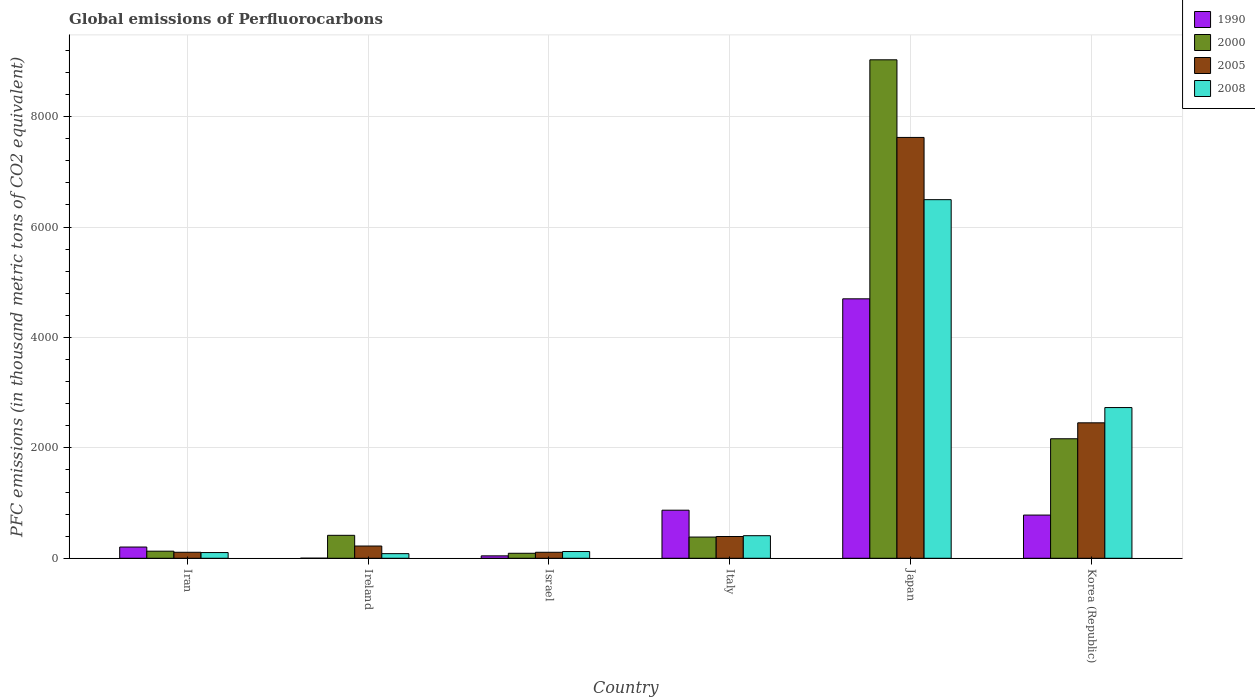How many different coloured bars are there?
Offer a very short reply. 4. Are the number of bars per tick equal to the number of legend labels?
Your answer should be compact. Yes. How many bars are there on the 2nd tick from the right?
Give a very brief answer. 4. What is the label of the 4th group of bars from the left?
Provide a succinct answer. Italy. In how many cases, is the number of bars for a given country not equal to the number of legend labels?
Your answer should be very brief. 0. What is the global emissions of Perfluorocarbons in 2008 in Japan?
Offer a terse response. 6496.1. Across all countries, what is the maximum global emissions of Perfluorocarbons in 2008?
Give a very brief answer. 6496.1. Across all countries, what is the minimum global emissions of Perfluorocarbons in 2008?
Offer a very short reply. 83.6. In which country was the global emissions of Perfluorocarbons in 2008 minimum?
Give a very brief answer. Ireland. What is the total global emissions of Perfluorocarbons in 2000 in the graph?
Your answer should be very brief. 1.22e+04. What is the difference between the global emissions of Perfluorocarbons in 2005 in Iran and that in Israel?
Make the answer very short. -0.2. What is the difference between the global emissions of Perfluorocarbons in 2000 in Iran and the global emissions of Perfluorocarbons in 2008 in Italy?
Give a very brief answer. -280.3. What is the average global emissions of Perfluorocarbons in 2000 per country?
Make the answer very short. 2035.6. What is the difference between the global emissions of Perfluorocarbons of/in 1990 and global emissions of Perfluorocarbons of/in 2008 in Japan?
Offer a terse response. -1796.1. In how many countries, is the global emissions of Perfluorocarbons in 2000 greater than 5600 thousand metric tons?
Provide a short and direct response. 1. What is the ratio of the global emissions of Perfluorocarbons in 1990 in Israel to that in Italy?
Your answer should be compact. 0.05. Is the difference between the global emissions of Perfluorocarbons in 1990 in Israel and Italy greater than the difference between the global emissions of Perfluorocarbons in 2008 in Israel and Italy?
Make the answer very short. No. What is the difference between the highest and the second highest global emissions of Perfluorocarbons in 2008?
Ensure brevity in your answer.  3766. What is the difference between the highest and the lowest global emissions of Perfluorocarbons in 2005?
Your answer should be very brief. 7515.1. In how many countries, is the global emissions of Perfluorocarbons in 1990 greater than the average global emissions of Perfluorocarbons in 1990 taken over all countries?
Offer a terse response. 1. What does the 1st bar from the left in Italy represents?
Your answer should be compact. 1990. What does the 1st bar from the right in Italy represents?
Provide a succinct answer. 2008. Is it the case that in every country, the sum of the global emissions of Perfluorocarbons in 1990 and global emissions of Perfluorocarbons in 2000 is greater than the global emissions of Perfluorocarbons in 2008?
Provide a succinct answer. Yes. Are all the bars in the graph horizontal?
Offer a very short reply. No. What is the difference between two consecutive major ticks on the Y-axis?
Ensure brevity in your answer.  2000. Are the values on the major ticks of Y-axis written in scientific E-notation?
Make the answer very short. No. Does the graph contain grids?
Your answer should be compact. Yes. Where does the legend appear in the graph?
Ensure brevity in your answer.  Top right. How are the legend labels stacked?
Make the answer very short. Vertical. What is the title of the graph?
Offer a terse response. Global emissions of Perfluorocarbons. What is the label or title of the Y-axis?
Provide a succinct answer. PFC emissions (in thousand metric tons of CO2 equivalent). What is the PFC emissions (in thousand metric tons of CO2 equivalent) of 1990 in Iran?
Offer a very short reply. 203.5. What is the PFC emissions (in thousand metric tons of CO2 equivalent) of 2000 in Iran?
Offer a terse response. 128.5. What is the PFC emissions (in thousand metric tons of CO2 equivalent) in 2005 in Iran?
Offer a very short reply. 108.5. What is the PFC emissions (in thousand metric tons of CO2 equivalent) of 2008 in Iran?
Give a very brief answer. 103.6. What is the PFC emissions (in thousand metric tons of CO2 equivalent) of 2000 in Ireland?
Keep it short and to the point. 415.6. What is the PFC emissions (in thousand metric tons of CO2 equivalent) of 2005 in Ireland?
Make the answer very short. 221.8. What is the PFC emissions (in thousand metric tons of CO2 equivalent) in 2008 in Ireland?
Your response must be concise. 83.6. What is the PFC emissions (in thousand metric tons of CO2 equivalent) in 1990 in Israel?
Your answer should be very brief. 43.8. What is the PFC emissions (in thousand metric tons of CO2 equivalent) of 2000 in Israel?
Offer a terse response. 90.5. What is the PFC emissions (in thousand metric tons of CO2 equivalent) of 2005 in Israel?
Give a very brief answer. 108.7. What is the PFC emissions (in thousand metric tons of CO2 equivalent) in 2008 in Israel?
Offer a very short reply. 122.3. What is the PFC emissions (in thousand metric tons of CO2 equivalent) in 1990 in Italy?
Provide a short and direct response. 871. What is the PFC emissions (in thousand metric tons of CO2 equivalent) of 2000 in Italy?
Your response must be concise. 384.3. What is the PFC emissions (in thousand metric tons of CO2 equivalent) of 2005 in Italy?
Give a very brief answer. 394.3. What is the PFC emissions (in thousand metric tons of CO2 equivalent) in 2008 in Italy?
Ensure brevity in your answer.  408.8. What is the PFC emissions (in thousand metric tons of CO2 equivalent) in 1990 in Japan?
Provide a succinct answer. 4700. What is the PFC emissions (in thousand metric tons of CO2 equivalent) of 2000 in Japan?
Offer a very short reply. 9029.8. What is the PFC emissions (in thousand metric tons of CO2 equivalent) of 2005 in Japan?
Your answer should be very brief. 7623.6. What is the PFC emissions (in thousand metric tons of CO2 equivalent) of 2008 in Japan?
Make the answer very short. 6496.1. What is the PFC emissions (in thousand metric tons of CO2 equivalent) of 1990 in Korea (Republic)?
Keep it short and to the point. 782.6. What is the PFC emissions (in thousand metric tons of CO2 equivalent) of 2000 in Korea (Republic)?
Provide a succinct answer. 2164.9. What is the PFC emissions (in thousand metric tons of CO2 equivalent) in 2005 in Korea (Republic)?
Ensure brevity in your answer.  2453.7. What is the PFC emissions (in thousand metric tons of CO2 equivalent) of 2008 in Korea (Republic)?
Your answer should be very brief. 2730.1. Across all countries, what is the maximum PFC emissions (in thousand metric tons of CO2 equivalent) of 1990?
Provide a succinct answer. 4700. Across all countries, what is the maximum PFC emissions (in thousand metric tons of CO2 equivalent) in 2000?
Your answer should be compact. 9029.8. Across all countries, what is the maximum PFC emissions (in thousand metric tons of CO2 equivalent) in 2005?
Offer a terse response. 7623.6. Across all countries, what is the maximum PFC emissions (in thousand metric tons of CO2 equivalent) of 2008?
Your answer should be compact. 6496.1. Across all countries, what is the minimum PFC emissions (in thousand metric tons of CO2 equivalent) of 1990?
Keep it short and to the point. 1.4. Across all countries, what is the minimum PFC emissions (in thousand metric tons of CO2 equivalent) of 2000?
Provide a short and direct response. 90.5. Across all countries, what is the minimum PFC emissions (in thousand metric tons of CO2 equivalent) of 2005?
Offer a very short reply. 108.5. Across all countries, what is the minimum PFC emissions (in thousand metric tons of CO2 equivalent) of 2008?
Your response must be concise. 83.6. What is the total PFC emissions (in thousand metric tons of CO2 equivalent) of 1990 in the graph?
Give a very brief answer. 6602.3. What is the total PFC emissions (in thousand metric tons of CO2 equivalent) in 2000 in the graph?
Provide a succinct answer. 1.22e+04. What is the total PFC emissions (in thousand metric tons of CO2 equivalent) in 2005 in the graph?
Make the answer very short. 1.09e+04. What is the total PFC emissions (in thousand metric tons of CO2 equivalent) in 2008 in the graph?
Your answer should be very brief. 9944.5. What is the difference between the PFC emissions (in thousand metric tons of CO2 equivalent) in 1990 in Iran and that in Ireland?
Ensure brevity in your answer.  202.1. What is the difference between the PFC emissions (in thousand metric tons of CO2 equivalent) in 2000 in Iran and that in Ireland?
Give a very brief answer. -287.1. What is the difference between the PFC emissions (in thousand metric tons of CO2 equivalent) of 2005 in Iran and that in Ireland?
Keep it short and to the point. -113.3. What is the difference between the PFC emissions (in thousand metric tons of CO2 equivalent) of 2008 in Iran and that in Ireland?
Make the answer very short. 20. What is the difference between the PFC emissions (in thousand metric tons of CO2 equivalent) in 1990 in Iran and that in Israel?
Provide a short and direct response. 159.7. What is the difference between the PFC emissions (in thousand metric tons of CO2 equivalent) of 2000 in Iran and that in Israel?
Your response must be concise. 38. What is the difference between the PFC emissions (in thousand metric tons of CO2 equivalent) of 2005 in Iran and that in Israel?
Keep it short and to the point. -0.2. What is the difference between the PFC emissions (in thousand metric tons of CO2 equivalent) of 2008 in Iran and that in Israel?
Your response must be concise. -18.7. What is the difference between the PFC emissions (in thousand metric tons of CO2 equivalent) in 1990 in Iran and that in Italy?
Offer a terse response. -667.5. What is the difference between the PFC emissions (in thousand metric tons of CO2 equivalent) of 2000 in Iran and that in Italy?
Your answer should be compact. -255.8. What is the difference between the PFC emissions (in thousand metric tons of CO2 equivalent) in 2005 in Iran and that in Italy?
Provide a short and direct response. -285.8. What is the difference between the PFC emissions (in thousand metric tons of CO2 equivalent) in 2008 in Iran and that in Italy?
Your response must be concise. -305.2. What is the difference between the PFC emissions (in thousand metric tons of CO2 equivalent) of 1990 in Iran and that in Japan?
Your response must be concise. -4496.5. What is the difference between the PFC emissions (in thousand metric tons of CO2 equivalent) of 2000 in Iran and that in Japan?
Offer a terse response. -8901.3. What is the difference between the PFC emissions (in thousand metric tons of CO2 equivalent) in 2005 in Iran and that in Japan?
Provide a short and direct response. -7515.1. What is the difference between the PFC emissions (in thousand metric tons of CO2 equivalent) in 2008 in Iran and that in Japan?
Your answer should be very brief. -6392.5. What is the difference between the PFC emissions (in thousand metric tons of CO2 equivalent) in 1990 in Iran and that in Korea (Republic)?
Your answer should be very brief. -579.1. What is the difference between the PFC emissions (in thousand metric tons of CO2 equivalent) in 2000 in Iran and that in Korea (Republic)?
Offer a very short reply. -2036.4. What is the difference between the PFC emissions (in thousand metric tons of CO2 equivalent) of 2005 in Iran and that in Korea (Republic)?
Keep it short and to the point. -2345.2. What is the difference between the PFC emissions (in thousand metric tons of CO2 equivalent) in 2008 in Iran and that in Korea (Republic)?
Give a very brief answer. -2626.5. What is the difference between the PFC emissions (in thousand metric tons of CO2 equivalent) of 1990 in Ireland and that in Israel?
Offer a terse response. -42.4. What is the difference between the PFC emissions (in thousand metric tons of CO2 equivalent) in 2000 in Ireland and that in Israel?
Offer a terse response. 325.1. What is the difference between the PFC emissions (in thousand metric tons of CO2 equivalent) of 2005 in Ireland and that in Israel?
Make the answer very short. 113.1. What is the difference between the PFC emissions (in thousand metric tons of CO2 equivalent) of 2008 in Ireland and that in Israel?
Your response must be concise. -38.7. What is the difference between the PFC emissions (in thousand metric tons of CO2 equivalent) in 1990 in Ireland and that in Italy?
Provide a succinct answer. -869.6. What is the difference between the PFC emissions (in thousand metric tons of CO2 equivalent) in 2000 in Ireland and that in Italy?
Offer a very short reply. 31.3. What is the difference between the PFC emissions (in thousand metric tons of CO2 equivalent) in 2005 in Ireland and that in Italy?
Your answer should be compact. -172.5. What is the difference between the PFC emissions (in thousand metric tons of CO2 equivalent) of 2008 in Ireland and that in Italy?
Give a very brief answer. -325.2. What is the difference between the PFC emissions (in thousand metric tons of CO2 equivalent) in 1990 in Ireland and that in Japan?
Your answer should be very brief. -4698.6. What is the difference between the PFC emissions (in thousand metric tons of CO2 equivalent) of 2000 in Ireland and that in Japan?
Make the answer very short. -8614.2. What is the difference between the PFC emissions (in thousand metric tons of CO2 equivalent) in 2005 in Ireland and that in Japan?
Your answer should be very brief. -7401.8. What is the difference between the PFC emissions (in thousand metric tons of CO2 equivalent) in 2008 in Ireland and that in Japan?
Provide a short and direct response. -6412.5. What is the difference between the PFC emissions (in thousand metric tons of CO2 equivalent) in 1990 in Ireland and that in Korea (Republic)?
Provide a short and direct response. -781.2. What is the difference between the PFC emissions (in thousand metric tons of CO2 equivalent) of 2000 in Ireland and that in Korea (Republic)?
Make the answer very short. -1749.3. What is the difference between the PFC emissions (in thousand metric tons of CO2 equivalent) in 2005 in Ireland and that in Korea (Republic)?
Ensure brevity in your answer.  -2231.9. What is the difference between the PFC emissions (in thousand metric tons of CO2 equivalent) in 2008 in Ireland and that in Korea (Republic)?
Give a very brief answer. -2646.5. What is the difference between the PFC emissions (in thousand metric tons of CO2 equivalent) of 1990 in Israel and that in Italy?
Make the answer very short. -827.2. What is the difference between the PFC emissions (in thousand metric tons of CO2 equivalent) of 2000 in Israel and that in Italy?
Provide a short and direct response. -293.8. What is the difference between the PFC emissions (in thousand metric tons of CO2 equivalent) of 2005 in Israel and that in Italy?
Offer a terse response. -285.6. What is the difference between the PFC emissions (in thousand metric tons of CO2 equivalent) of 2008 in Israel and that in Italy?
Give a very brief answer. -286.5. What is the difference between the PFC emissions (in thousand metric tons of CO2 equivalent) of 1990 in Israel and that in Japan?
Offer a very short reply. -4656.2. What is the difference between the PFC emissions (in thousand metric tons of CO2 equivalent) of 2000 in Israel and that in Japan?
Provide a succinct answer. -8939.3. What is the difference between the PFC emissions (in thousand metric tons of CO2 equivalent) of 2005 in Israel and that in Japan?
Your response must be concise. -7514.9. What is the difference between the PFC emissions (in thousand metric tons of CO2 equivalent) in 2008 in Israel and that in Japan?
Your answer should be compact. -6373.8. What is the difference between the PFC emissions (in thousand metric tons of CO2 equivalent) in 1990 in Israel and that in Korea (Republic)?
Keep it short and to the point. -738.8. What is the difference between the PFC emissions (in thousand metric tons of CO2 equivalent) of 2000 in Israel and that in Korea (Republic)?
Make the answer very short. -2074.4. What is the difference between the PFC emissions (in thousand metric tons of CO2 equivalent) in 2005 in Israel and that in Korea (Republic)?
Your answer should be very brief. -2345. What is the difference between the PFC emissions (in thousand metric tons of CO2 equivalent) in 2008 in Israel and that in Korea (Republic)?
Your answer should be very brief. -2607.8. What is the difference between the PFC emissions (in thousand metric tons of CO2 equivalent) of 1990 in Italy and that in Japan?
Make the answer very short. -3829. What is the difference between the PFC emissions (in thousand metric tons of CO2 equivalent) of 2000 in Italy and that in Japan?
Give a very brief answer. -8645.5. What is the difference between the PFC emissions (in thousand metric tons of CO2 equivalent) of 2005 in Italy and that in Japan?
Offer a terse response. -7229.3. What is the difference between the PFC emissions (in thousand metric tons of CO2 equivalent) in 2008 in Italy and that in Japan?
Offer a very short reply. -6087.3. What is the difference between the PFC emissions (in thousand metric tons of CO2 equivalent) of 1990 in Italy and that in Korea (Republic)?
Offer a terse response. 88.4. What is the difference between the PFC emissions (in thousand metric tons of CO2 equivalent) in 2000 in Italy and that in Korea (Republic)?
Offer a terse response. -1780.6. What is the difference between the PFC emissions (in thousand metric tons of CO2 equivalent) in 2005 in Italy and that in Korea (Republic)?
Your response must be concise. -2059.4. What is the difference between the PFC emissions (in thousand metric tons of CO2 equivalent) in 2008 in Italy and that in Korea (Republic)?
Offer a very short reply. -2321.3. What is the difference between the PFC emissions (in thousand metric tons of CO2 equivalent) in 1990 in Japan and that in Korea (Republic)?
Provide a succinct answer. 3917.4. What is the difference between the PFC emissions (in thousand metric tons of CO2 equivalent) of 2000 in Japan and that in Korea (Republic)?
Make the answer very short. 6864.9. What is the difference between the PFC emissions (in thousand metric tons of CO2 equivalent) in 2005 in Japan and that in Korea (Republic)?
Offer a very short reply. 5169.9. What is the difference between the PFC emissions (in thousand metric tons of CO2 equivalent) of 2008 in Japan and that in Korea (Republic)?
Keep it short and to the point. 3766. What is the difference between the PFC emissions (in thousand metric tons of CO2 equivalent) of 1990 in Iran and the PFC emissions (in thousand metric tons of CO2 equivalent) of 2000 in Ireland?
Offer a terse response. -212.1. What is the difference between the PFC emissions (in thousand metric tons of CO2 equivalent) of 1990 in Iran and the PFC emissions (in thousand metric tons of CO2 equivalent) of 2005 in Ireland?
Ensure brevity in your answer.  -18.3. What is the difference between the PFC emissions (in thousand metric tons of CO2 equivalent) in 1990 in Iran and the PFC emissions (in thousand metric tons of CO2 equivalent) in 2008 in Ireland?
Your answer should be compact. 119.9. What is the difference between the PFC emissions (in thousand metric tons of CO2 equivalent) in 2000 in Iran and the PFC emissions (in thousand metric tons of CO2 equivalent) in 2005 in Ireland?
Keep it short and to the point. -93.3. What is the difference between the PFC emissions (in thousand metric tons of CO2 equivalent) of 2000 in Iran and the PFC emissions (in thousand metric tons of CO2 equivalent) of 2008 in Ireland?
Make the answer very short. 44.9. What is the difference between the PFC emissions (in thousand metric tons of CO2 equivalent) in 2005 in Iran and the PFC emissions (in thousand metric tons of CO2 equivalent) in 2008 in Ireland?
Your response must be concise. 24.9. What is the difference between the PFC emissions (in thousand metric tons of CO2 equivalent) of 1990 in Iran and the PFC emissions (in thousand metric tons of CO2 equivalent) of 2000 in Israel?
Make the answer very short. 113. What is the difference between the PFC emissions (in thousand metric tons of CO2 equivalent) in 1990 in Iran and the PFC emissions (in thousand metric tons of CO2 equivalent) in 2005 in Israel?
Provide a succinct answer. 94.8. What is the difference between the PFC emissions (in thousand metric tons of CO2 equivalent) of 1990 in Iran and the PFC emissions (in thousand metric tons of CO2 equivalent) of 2008 in Israel?
Make the answer very short. 81.2. What is the difference between the PFC emissions (in thousand metric tons of CO2 equivalent) of 2000 in Iran and the PFC emissions (in thousand metric tons of CO2 equivalent) of 2005 in Israel?
Offer a very short reply. 19.8. What is the difference between the PFC emissions (in thousand metric tons of CO2 equivalent) in 2005 in Iran and the PFC emissions (in thousand metric tons of CO2 equivalent) in 2008 in Israel?
Provide a short and direct response. -13.8. What is the difference between the PFC emissions (in thousand metric tons of CO2 equivalent) of 1990 in Iran and the PFC emissions (in thousand metric tons of CO2 equivalent) of 2000 in Italy?
Your response must be concise. -180.8. What is the difference between the PFC emissions (in thousand metric tons of CO2 equivalent) of 1990 in Iran and the PFC emissions (in thousand metric tons of CO2 equivalent) of 2005 in Italy?
Offer a terse response. -190.8. What is the difference between the PFC emissions (in thousand metric tons of CO2 equivalent) in 1990 in Iran and the PFC emissions (in thousand metric tons of CO2 equivalent) in 2008 in Italy?
Make the answer very short. -205.3. What is the difference between the PFC emissions (in thousand metric tons of CO2 equivalent) in 2000 in Iran and the PFC emissions (in thousand metric tons of CO2 equivalent) in 2005 in Italy?
Provide a short and direct response. -265.8. What is the difference between the PFC emissions (in thousand metric tons of CO2 equivalent) of 2000 in Iran and the PFC emissions (in thousand metric tons of CO2 equivalent) of 2008 in Italy?
Provide a succinct answer. -280.3. What is the difference between the PFC emissions (in thousand metric tons of CO2 equivalent) in 2005 in Iran and the PFC emissions (in thousand metric tons of CO2 equivalent) in 2008 in Italy?
Keep it short and to the point. -300.3. What is the difference between the PFC emissions (in thousand metric tons of CO2 equivalent) of 1990 in Iran and the PFC emissions (in thousand metric tons of CO2 equivalent) of 2000 in Japan?
Provide a short and direct response. -8826.3. What is the difference between the PFC emissions (in thousand metric tons of CO2 equivalent) in 1990 in Iran and the PFC emissions (in thousand metric tons of CO2 equivalent) in 2005 in Japan?
Your answer should be compact. -7420.1. What is the difference between the PFC emissions (in thousand metric tons of CO2 equivalent) of 1990 in Iran and the PFC emissions (in thousand metric tons of CO2 equivalent) of 2008 in Japan?
Make the answer very short. -6292.6. What is the difference between the PFC emissions (in thousand metric tons of CO2 equivalent) of 2000 in Iran and the PFC emissions (in thousand metric tons of CO2 equivalent) of 2005 in Japan?
Provide a succinct answer. -7495.1. What is the difference between the PFC emissions (in thousand metric tons of CO2 equivalent) in 2000 in Iran and the PFC emissions (in thousand metric tons of CO2 equivalent) in 2008 in Japan?
Offer a very short reply. -6367.6. What is the difference between the PFC emissions (in thousand metric tons of CO2 equivalent) of 2005 in Iran and the PFC emissions (in thousand metric tons of CO2 equivalent) of 2008 in Japan?
Provide a succinct answer. -6387.6. What is the difference between the PFC emissions (in thousand metric tons of CO2 equivalent) of 1990 in Iran and the PFC emissions (in thousand metric tons of CO2 equivalent) of 2000 in Korea (Republic)?
Your answer should be compact. -1961.4. What is the difference between the PFC emissions (in thousand metric tons of CO2 equivalent) in 1990 in Iran and the PFC emissions (in thousand metric tons of CO2 equivalent) in 2005 in Korea (Republic)?
Keep it short and to the point. -2250.2. What is the difference between the PFC emissions (in thousand metric tons of CO2 equivalent) in 1990 in Iran and the PFC emissions (in thousand metric tons of CO2 equivalent) in 2008 in Korea (Republic)?
Your answer should be very brief. -2526.6. What is the difference between the PFC emissions (in thousand metric tons of CO2 equivalent) of 2000 in Iran and the PFC emissions (in thousand metric tons of CO2 equivalent) of 2005 in Korea (Republic)?
Keep it short and to the point. -2325.2. What is the difference between the PFC emissions (in thousand metric tons of CO2 equivalent) in 2000 in Iran and the PFC emissions (in thousand metric tons of CO2 equivalent) in 2008 in Korea (Republic)?
Provide a succinct answer. -2601.6. What is the difference between the PFC emissions (in thousand metric tons of CO2 equivalent) of 2005 in Iran and the PFC emissions (in thousand metric tons of CO2 equivalent) of 2008 in Korea (Republic)?
Make the answer very short. -2621.6. What is the difference between the PFC emissions (in thousand metric tons of CO2 equivalent) of 1990 in Ireland and the PFC emissions (in thousand metric tons of CO2 equivalent) of 2000 in Israel?
Provide a succinct answer. -89.1. What is the difference between the PFC emissions (in thousand metric tons of CO2 equivalent) in 1990 in Ireland and the PFC emissions (in thousand metric tons of CO2 equivalent) in 2005 in Israel?
Keep it short and to the point. -107.3. What is the difference between the PFC emissions (in thousand metric tons of CO2 equivalent) of 1990 in Ireland and the PFC emissions (in thousand metric tons of CO2 equivalent) of 2008 in Israel?
Ensure brevity in your answer.  -120.9. What is the difference between the PFC emissions (in thousand metric tons of CO2 equivalent) in 2000 in Ireland and the PFC emissions (in thousand metric tons of CO2 equivalent) in 2005 in Israel?
Your answer should be very brief. 306.9. What is the difference between the PFC emissions (in thousand metric tons of CO2 equivalent) of 2000 in Ireland and the PFC emissions (in thousand metric tons of CO2 equivalent) of 2008 in Israel?
Offer a very short reply. 293.3. What is the difference between the PFC emissions (in thousand metric tons of CO2 equivalent) in 2005 in Ireland and the PFC emissions (in thousand metric tons of CO2 equivalent) in 2008 in Israel?
Your answer should be compact. 99.5. What is the difference between the PFC emissions (in thousand metric tons of CO2 equivalent) of 1990 in Ireland and the PFC emissions (in thousand metric tons of CO2 equivalent) of 2000 in Italy?
Your answer should be very brief. -382.9. What is the difference between the PFC emissions (in thousand metric tons of CO2 equivalent) in 1990 in Ireland and the PFC emissions (in thousand metric tons of CO2 equivalent) in 2005 in Italy?
Give a very brief answer. -392.9. What is the difference between the PFC emissions (in thousand metric tons of CO2 equivalent) of 1990 in Ireland and the PFC emissions (in thousand metric tons of CO2 equivalent) of 2008 in Italy?
Provide a succinct answer. -407.4. What is the difference between the PFC emissions (in thousand metric tons of CO2 equivalent) of 2000 in Ireland and the PFC emissions (in thousand metric tons of CO2 equivalent) of 2005 in Italy?
Provide a succinct answer. 21.3. What is the difference between the PFC emissions (in thousand metric tons of CO2 equivalent) of 2000 in Ireland and the PFC emissions (in thousand metric tons of CO2 equivalent) of 2008 in Italy?
Your response must be concise. 6.8. What is the difference between the PFC emissions (in thousand metric tons of CO2 equivalent) in 2005 in Ireland and the PFC emissions (in thousand metric tons of CO2 equivalent) in 2008 in Italy?
Your answer should be compact. -187. What is the difference between the PFC emissions (in thousand metric tons of CO2 equivalent) of 1990 in Ireland and the PFC emissions (in thousand metric tons of CO2 equivalent) of 2000 in Japan?
Give a very brief answer. -9028.4. What is the difference between the PFC emissions (in thousand metric tons of CO2 equivalent) of 1990 in Ireland and the PFC emissions (in thousand metric tons of CO2 equivalent) of 2005 in Japan?
Offer a terse response. -7622.2. What is the difference between the PFC emissions (in thousand metric tons of CO2 equivalent) in 1990 in Ireland and the PFC emissions (in thousand metric tons of CO2 equivalent) in 2008 in Japan?
Your answer should be compact. -6494.7. What is the difference between the PFC emissions (in thousand metric tons of CO2 equivalent) of 2000 in Ireland and the PFC emissions (in thousand metric tons of CO2 equivalent) of 2005 in Japan?
Give a very brief answer. -7208. What is the difference between the PFC emissions (in thousand metric tons of CO2 equivalent) in 2000 in Ireland and the PFC emissions (in thousand metric tons of CO2 equivalent) in 2008 in Japan?
Provide a short and direct response. -6080.5. What is the difference between the PFC emissions (in thousand metric tons of CO2 equivalent) of 2005 in Ireland and the PFC emissions (in thousand metric tons of CO2 equivalent) of 2008 in Japan?
Provide a succinct answer. -6274.3. What is the difference between the PFC emissions (in thousand metric tons of CO2 equivalent) in 1990 in Ireland and the PFC emissions (in thousand metric tons of CO2 equivalent) in 2000 in Korea (Republic)?
Offer a very short reply. -2163.5. What is the difference between the PFC emissions (in thousand metric tons of CO2 equivalent) in 1990 in Ireland and the PFC emissions (in thousand metric tons of CO2 equivalent) in 2005 in Korea (Republic)?
Your answer should be compact. -2452.3. What is the difference between the PFC emissions (in thousand metric tons of CO2 equivalent) in 1990 in Ireland and the PFC emissions (in thousand metric tons of CO2 equivalent) in 2008 in Korea (Republic)?
Provide a short and direct response. -2728.7. What is the difference between the PFC emissions (in thousand metric tons of CO2 equivalent) of 2000 in Ireland and the PFC emissions (in thousand metric tons of CO2 equivalent) of 2005 in Korea (Republic)?
Provide a succinct answer. -2038.1. What is the difference between the PFC emissions (in thousand metric tons of CO2 equivalent) in 2000 in Ireland and the PFC emissions (in thousand metric tons of CO2 equivalent) in 2008 in Korea (Republic)?
Offer a terse response. -2314.5. What is the difference between the PFC emissions (in thousand metric tons of CO2 equivalent) in 2005 in Ireland and the PFC emissions (in thousand metric tons of CO2 equivalent) in 2008 in Korea (Republic)?
Offer a terse response. -2508.3. What is the difference between the PFC emissions (in thousand metric tons of CO2 equivalent) in 1990 in Israel and the PFC emissions (in thousand metric tons of CO2 equivalent) in 2000 in Italy?
Ensure brevity in your answer.  -340.5. What is the difference between the PFC emissions (in thousand metric tons of CO2 equivalent) of 1990 in Israel and the PFC emissions (in thousand metric tons of CO2 equivalent) of 2005 in Italy?
Give a very brief answer. -350.5. What is the difference between the PFC emissions (in thousand metric tons of CO2 equivalent) of 1990 in Israel and the PFC emissions (in thousand metric tons of CO2 equivalent) of 2008 in Italy?
Your answer should be very brief. -365. What is the difference between the PFC emissions (in thousand metric tons of CO2 equivalent) of 2000 in Israel and the PFC emissions (in thousand metric tons of CO2 equivalent) of 2005 in Italy?
Your answer should be very brief. -303.8. What is the difference between the PFC emissions (in thousand metric tons of CO2 equivalent) of 2000 in Israel and the PFC emissions (in thousand metric tons of CO2 equivalent) of 2008 in Italy?
Ensure brevity in your answer.  -318.3. What is the difference between the PFC emissions (in thousand metric tons of CO2 equivalent) in 2005 in Israel and the PFC emissions (in thousand metric tons of CO2 equivalent) in 2008 in Italy?
Provide a succinct answer. -300.1. What is the difference between the PFC emissions (in thousand metric tons of CO2 equivalent) of 1990 in Israel and the PFC emissions (in thousand metric tons of CO2 equivalent) of 2000 in Japan?
Give a very brief answer. -8986. What is the difference between the PFC emissions (in thousand metric tons of CO2 equivalent) in 1990 in Israel and the PFC emissions (in thousand metric tons of CO2 equivalent) in 2005 in Japan?
Your answer should be very brief. -7579.8. What is the difference between the PFC emissions (in thousand metric tons of CO2 equivalent) in 1990 in Israel and the PFC emissions (in thousand metric tons of CO2 equivalent) in 2008 in Japan?
Keep it short and to the point. -6452.3. What is the difference between the PFC emissions (in thousand metric tons of CO2 equivalent) of 2000 in Israel and the PFC emissions (in thousand metric tons of CO2 equivalent) of 2005 in Japan?
Your answer should be very brief. -7533.1. What is the difference between the PFC emissions (in thousand metric tons of CO2 equivalent) of 2000 in Israel and the PFC emissions (in thousand metric tons of CO2 equivalent) of 2008 in Japan?
Ensure brevity in your answer.  -6405.6. What is the difference between the PFC emissions (in thousand metric tons of CO2 equivalent) of 2005 in Israel and the PFC emissions (in thousand metric tons of CO2 equivalent) of 2008 in Japan?
Your answer should be compact. -6387.4. What is the difference between the PFC emissions (in thousand metric tons of CO2 equivalent) in 1990 in Israel and the PFC emissions (in thousand metric tons of CO2 equivalent) in 2000 in Korea (Republic)?
Offer a terse response. -2121.1. What is the difference between the PFC emissions (in thousand metric tons of CO2 equivalent) of 1990 in Israel and the PFC emissions (in thousand metric tons of CO2 equivalent) of 2005 in Korea (Republic)?
Offer a terse response. -2409.9. What is the difference between the PFC emissions (in thousand metric tons of CO2 equivalent) in 1990 in Israel and the PFC emissions (in thousand metric tons of CO2 equivalent) in 2008 in Korea (Republic)?
Offer a terse response. -2686.3. What is the difference between the PFC emissions (in thousand metric tons of CO2 equivalent) of 2000 in Israel and the PFC emissions (in thousand metric tons of CO2 equivalent) of 2005 in Korea (Republic)?
Give a very brief answer. -2363.2. What is the difference between the PFC emissions (in thousand metric tons of CO2 equivalent) of 2000 in Israel and the PFC emissions (in thousand metric tons of CO2 equivalent) of 2008 in Korea (Republic)?
Offer a very short reply. -2639.6. What is the difference between the PFC emissions (in thousand metric tons of CO2 equivalent) in 2005 in Israel and the PFC emissions (in thousand metric tons of CO2 equivalent) in 2008 in Korea (Republic)?
Provide a succinct answer. -2621.4. What is the difference between the PFC emissions (in thousand metric tons of CO2 equivalent) in 1990 in Italy and the PFC emissions (in thousand metric tons of CO2 equivalent) in 2000 in Japan?
Make the answer very short. -8158.8. What is the difference between the PFC emissions (in thousand metric tons of CO2 equivalent) of 1990 in Italy and the PFC emissions (in thousand metric tons of CO2 equivalent) of 2005 in Japan?
Offer a terse response. -6752.6. What is the difference between the PFC emissions (in thousand metric tons of CO2 equivalent) in 1990 in Italy and the PFC emissions (in thousand metric tons of CO2 equivalent) in 2008 in Japan?
Ensure brevity in your answer.  -5625.1. What is the difference between the PFC emissions (in thousand metric tons of CO2 equivalent) in 2000 in Italy and the PFC emissions (in thousand metric tons of CO2 equivalent) in 2005 in Japan?
Your response must be concise. -7239.3. What is the difference between the PFC emissions (in thousand metric tons of CO2 equivalent) in 2000 in Italy and the PFC emissions (in thousand metric tons of CO2 equivalent) in 2008 in Japan?
Make the answer very short. -6111.8. What is the difference between the PFC emissions (in thousand metric tons of CO2 equivalent) in 2005 in Italy and the PFC emissions (in thousand metric tons of CO2 equivalent) in 2008 in Japan?
Keep it short and to the point. -6101.8. What is the difference between the PFC emissions (in thousand metric tons of CO2 equivalent) of 1990 in Italy and the PFC emissions (in thousand metric tons of CO2 equivalent) of 2000 in Korea (Republic)?
Provide a succinct answer. -1293.9. What is the difference between the PFC emissions (in thousand metric tons of CO2 equivalent) in 1990 in Italy and the PFC emissions (in thousand metric tons of CO2 equivalent) in 2005 in Korea (Republic)?
Provide a short and direct response. -1582.7. What is the difference between the PFC emissions (in thousand metric tons of CO2 equivalent) of 1990 in Italy and the PFC emissions (in thousand metric tons of CO2 equivalent) of 2008 in Korea (Republic)?
Your answer should be very brief. -1859.1. What is the difference between the PFC emissions (in thousand metric tons of CO2 equivalent) of 2000 in Italy and the PFC emissions (in thousand metric tons of CO2 equivalent) of 2005 in Korea (Republic)?
Give a very brief answer. -2069.4. What is the difference between the PFC emissions (in thousand metric tons of CO2 equivalent) in 2000 in Italy and the PFC emissions (in thousand metric tons of CO2 equivalent) in 2008 in Korea (Republic)?
Your answer should be very brief. -2345.8. What is the difference between the PFC emissions (in thousand metric tons of CO2 equivalent) of 2005 in Italy and the PFC emissions (in thousand metric tons of CO2 equivalent) of 2008 in Korea (Republic)?
Provide a short and direct response. -2335.8. What is the difference between the PFC emissions (in thousand metric tons of CO2 equivalent) of 1990 in Japan and the PFC emissions (in thousand metric tons of CO2 equivalent) of 2000 in Korea (Republic)?
Provide a succinct answer. 2535.1. What is the difference between the PFC emissions (in thousand metric tons of CO2 equivalent) in 1990 in Japan and the PFC emissions (in thousand metric tons of CO2 equivalent) in 2005 in Korea (Republic)?
Ensure brevity in your answer.  2246.3. What is the difference between the PFC emissions (in thousand metric tons of CO2 equivalent) in 1990 in Japan and the PFC emissions (in thousand metric tons of CO2 equivalent) in 2008 in Korea (Republic)?
Make the answer very short. 1969.9. What is the difference between the PFC emissions (in thousand metric tons of CO2 equivalent) in 2000 in Japan and the PFC emissions (in thousand metric tons of CO2 equivalent) in 2005 in Korea (Republic)?
Provide a succinct answer. 6576.1. What is the difference between the PFC emissions (in thousand metric tons of CO2 equivalent) of 2000 in Japan and the PFC emissions (in thousand metric tons of CO2 equivalent) of 2008 in Korea (Republic)?
Ensure brevity in your answer.  6299.7. What is the difference between the PFC emissions (in thousand metric tons of CO2 equivalent) of 2005 in Japan and the PFC emissions (in thousand metric tons of CO2 equivalent) of 2008 in Korea (Republic)?
Offer a terse response. 4893.5. What is the average PFC emissions (in thousand metric tons of CO2 equivalent) in 1990 per country?
Make the answer very short. 1100.38. What is the average PFC emissions (in thousand metric tons of CO2 equivalent) of 2000 per country?
Your response must be concise. 2035.6. What is the average PFC emissions (in thousand metric tons of CO2 equivalent) of 2005 per country?
Give a very brief answer. 1818.43. What is the average PFC emissions (in thousand metric tons of CO2 equivalent) of 2008 per country?
Keep it short and to the point. 1657.42. What is the difference between the PFC emissions (in thousand metric tons of CO2 equivalent) in 1990 and PFC emissions (in thousand metric tons of CO2 equivalent) in 2005 in Iran?
Your answer should be compact. 95. What is the difference between the PFC emissions (in thousand metric tons of CO2 equivalent) in 1990 and PFC emissions (in thousand metric tons of CO2 equivalent) in 2008 in Iran?
Your answer should be compact. 99.9. What is the difference between the PFC emissions (in thousand metric tons of CO2 equivalent) of 2000 and PFC emissions (in thousand metric tons of CO2 equivalent) of 2008 in Iran?
Give a very brief answer. 24.9. What is the difference between the PFC emissions (in thousand metric tons of CO2 equivalent) in 2005 and PFC emissions (in thousand metric tons of CO2 equivalent) in 2008 in Iran?
Offer a terse response. 4.9. What is the difference between the PFC emissions (in thousand metric tons of CO2 equivalent) of 1990 and PFC emissions (in thousand metric tons of CO2 equivalent) of 2000 in Ireland?
Keep it short and to the point. -414.2. What is the difference between the PFC emissions (in thousand metric tons of CO2 equivalent) in 1990 and PFC emissions (in thousand metric tons of CO2 equivalent) in 2005 in Ireland?
Offer a terse response. -220.4. What is the difference between the PFC emissions (in thousand metric tons of CO2 equivalent) of 1990 and PFC emissions (in thousand metric tons of CO2 equivalent) of 2008 in Ireland?
Provide a succinct answer. -82.2. What is the difference between the PFC emissions (in thousand metric tons of CO2 equivalent) of 2000 and PFC emissions (in thousand metric tons of CO2 equivalent) of 2005 in Ireland?
Offer a very short reply. 193.8. What is the difference between the PFC emissions (in thousand metric tons of CO2 equivalent) of 2000 and PFC emissions (in thousand metric tons of CO2 equivalent) of 2008 in Ireland?
Make the answer very short. 332. What is the difference between the PFC emissions (in thousand metric tons of CO2 equivalent) of 2005 and PFC emissions (in thousand metric tons of CO2 equivalent) of 2008 in Ireland?
Provide a short and direct response. 138.2. What is the difference between the PFC emissions (in thousand metric tons of CO2 equivalent) in 1990 and PFC emissions (in thousand metric tons of CO2 equivalent) in 2000 in Israel?
Your response must be concise. -46.7. What is the difference between the PFC emissions (in thousand metric tons of CO2 equivalent) in 1990 and PFC emissions (in thousand metric tons of CO2 equivalent) in 2005 in Israel?
Your response must be concise. -64.9. What is the difference between the PFC emissions (in thousand metric tons of CO2 equivalent) in 1990 and PFC emissions (in thousand metric tons of CO2 equivalent) in 2008 in Israel?
Your answer should be compact. -78.5. What is the difference between the PFC emissions (in thousand metric tons of CO2 equivalent) in 2000 and PFC emissions (in thousand metric tons of CO2 equivalent) in 2005 in Israel?
Ensure brevity in your answer.  -18.2. What is the difference between the PFC emissions (in thousand metric tons of CO2 equivalent) of 2000 and PFC emissions (in thousand metric tons of CO2 equivalent) of 2008 in Israel?
Offer a very short reply. -31.8. What is the difference between the PFC emissions (in thousand metric tons of CO2 equivalent) in 2005 and PFC emissions (in thousand metric tons of CO2 equivalent) in 2008 in Israel?
Make the answer very short. -13.6. What is the difference between the PFC emissions (in thousand metric tons of CO2 equivalent) of 1990 and PFC emissions (in thousand metric tons of CO2 equivalent) of 2000 in Italy?
Offer a terse response. 486.7. What is the difference between the PFC emissions (in thousand metric tons of CO2 equivalent) of 1990 and PFC emissions (in thousand metric tons of CO2 equivalent) of 2005 in Italy?
Give a very brief answer. 476.7. What is the difference between the PFC emissions (in thousand metric tons of CO2 equivalent) of 1990 and PFC emissions (in thousand metric tons of CO2 equivalent) of 2008 in Italy?
Give a very brief answer. 462.2. What is the difference between the PFC emissions (in thousand metric tons of CO2 equivalent) in 2000 and PFC emissions (in thousand metric tons of CO2 equivalent) in 2008 in Italy?
Keep it short and to the point. -24.5. What is the difference between the PFC emissions (in thousand metric tons of CO2 equivalent) in 1990 and PFC emissions (in thousand metric tons of CO2 equivalent) in 2000 in Japan?
Give a very brief answer. -4329.8. What is the difference between the PFC emissions (in thousand metric tons of CO2 equivalent) of 1990 and PFC emissions (in thousand metric tons of CO2 equivalent) of 2005 in Japan?
Offer a very short reply. -2923.6. What is the difference between the PFC emissions (in thousand metric tons of CO2 equivalent) of 1990 and PFC emissions (in thousand metric tons of CO2 equivalent) of 2008 in Japan?
Provide a succinct answer. -1796.1. What is the difference between the PFC emissions (in thousand metric tons of CO2 equivalent) of 2000 and PFC emissions (in thousand metric tons of CO2 equivalent) of 2005 in Japan?
Provide a short and direct response. 1406.2. What is the difference between the PFC emissions (in thousand metric tons of CO2 equivalent) in 2000 and PFC emissions (in thousand metric tons of CO2 equivalent) in 2008 in Japan?
Offer a very short reply. 2533.7. What is the difference between the PFC emissions (in thousand metric tons of CO2 equivalent) of 2005 and PFC emissions (in thousand metric tons of CO2 equivalent) of 2008 in Japan?
Provide a short and direct response. 1127.5. What is the difference between the PFC emissions (in thousand metric tons of CO2 equivalent) of 1990 and PFC emissions (in thousand metric tons of CO2 equivalent) of 2000 in Korea (Republic)?
Offer a very short reply. -1382.3. What is the difference between the PFC emissions (in thousand metric tons of CO2 equivalent) in 1990 and PFC emissions (in thousand metric tons of CO2 equivalent) in 2005 in Korea (Republic)?
Make the answer very short. -1671.1. What is the difference between the PFC emissions (in thousand metric tons of CO2 equivalent) of 1990 and PFC emissions (in thousand metric tons of CO2 equivalent) of 2008 in Korea (Republic)?
Provide a short and direct response. -1947.5. What is the difference between the PFC emissions (in thousand metric tons of CO2 equivalent) in 2000 and PFC emissions (in thousand metric tons of CO2 equivalent) in 2005 in Korea (Republic)?
Give a very brief answer. -288.8. What is the difference between the PFC emissions (in thousand metric tons of CO2 equivalent) in 2000 and PFC emissions (in thousand metric tons of CO2 equivalent) in 2008 in Korea (Republic)?
Keep it short and to the point. -565.2. What is the difference between the PFC emissions (in thousand metric tons of CO2 equivalent) in 2005 and PFC emissions (in thousand metric tons of CO2 equivalent) in 2008 in Korea (Republic)?
Provide a short and direct response. -276.4. What is the ratio of the PFC emissions (in thousand metric tons of CO2 equivalent) in 1990 in Iran to that in Ireland?
Your response must be concise. 145.36. What is the ratio of the PFC emissions (in thousand metric tons of CO2 equivalent) of 2000 in Iran to that in Ireland?
Give a very brief answer. 0.31. What is the ratio of the PFC emissions (in thousand metric tons of CO2 equivalent) in 2005 in Iran to that in Ireland?
Your answer should be very brief. 0.49. What is the ratio of the PFC emissions (in thousand metric tons of CO2 equivalent) in 2008 in Iran to that in Ireland?
Your answer should be compact. 1.24. What is the ratio of the PFC emissions (in thousand metric tons of CO2 equivalent) of 1990 in Iran to that in Israel?
Offer a terse response. 4.65. What is the ratio of the PFC emissions (in thousand metric tons of CO2 equivalent) of 2000 in Iran to that in Israel?
Keep it short and to the point. 1.42. What is the ratio of the PFC emissions (in thousand metric tons of CO2 equivalent) in 2008 in Iran to that in Israel?
Offer a terse response. 0.85. What is the ratio of the PFC emissions (in thousand metric tons of CO2 equivalent) in 1990 in Iran to that in Italy?
Ensure brevity in your answer.  0.23. What is the ratio of the PFC emissions (in thousand metric tons of CO2 equivalent) in 2000 in Iran to that in Italy?
Ensure brevity in your answer.  0.33. What is the ratio of the PFC emissions (in thousand metric tons of CO2 equivalent) of 2005 in Iran to that in Italy?
Make the answer very short. 0.28. What is the ratio of the PFC emissions (in thousand metric tons of CO2 equivalent) in 2008 in Iran to that in Italy?
Offer a very short reply. 0.25. What is the ratio of the PFC emissions (in thousand metric tons of CO2 equivalent) in 1990 in Iran to that in Japan?
Your answer should be compact. 0.04. What is the ratio of the PFC emissions (in thousand metric tons of CO2 equivalent) in 2000 in Iran to that in Japan?
Offer a terse response. 0.01. What is the ratio of the PFC emissions (in thousand metric tons of CO2 equivalent) of 2005 in Iran to that in Japan?
Your answer should be compact. 0.01. What is the ratio of the PFC emissions (in thousand metric tons of CO2 equivalent) of 2008 in Iran to that in Japan?
Offer a very short reply. 0.02. What is the ratio of the PFC emissions (in thousand metric tons of CO2 equivalent) of 1990 in Iran to that in Korea (Republic)?
Your response must be concise. 0.26. What is the ratio of the PFC emissions (in thousand metric tons of CO2 equivalent) in 2000 in Iran to that in Korea (Republic)?
Provide a succinct answer. 0.06. What is the ratio of the PFC emissions (in thousand metric tons of CO2 equivalent) in 2005 in Iran to that in Korea (Republic)?
Your answer should be compact. 0.04. What is the ratio of the PFC emissions (in thousand metric tons of CO2 equivalent) in 2008 in Iran to that in Korea (Republic)?
Your answer should be compact. 0.04. What is the ratio of the PFC emissions (in thousand metric tons of CO2 equivalent) of 1990 in Ireland to that in Israel?
Offer a very short reply. 0.03. What is the ratio of the PFC emissions (in thousand metric tons of CO2 equivalent) of 2000 in Ireland to that in Israel?
Your response must be concise. 4.59. What is the ratio of the PFC emissions (in thousand metric tons of CO2 equivalent) of 2005 in Ireland to that in Israel?
Offer a very short reply. 2.04. What is the ratio of the PFC emissions (in thousand metric tons of CO2 equivalent) of 2008 in Ireland to that in Israel?
Keep it short and to the point. 0.68. What is the ratio of the PFC emissions (in thousand metric tons of CO2 equivalent) in 1990 in Ireland to that in Italy?
Offer a very short reply. 0. What is the ratio of the PFC emissions (in thousand metric tons of CO2 equivalent) in 2000 in Ireland to that in Italy?
Your response must be concise. 1.08. What is the ratio of the PFC emissions (in thousand metric tons of CO2 equivalent) of 2005 in Ireland to that in Italy?
Your answer should be compact. 0.56. What is the ratio of the PFC emissions (in thousand metric tons of CO2 equivalent) of 2008 in Ireland to that in Italy?
Your response must be concise. 0.2. What is the ratio of the PFC emissions (in thousand metric tons of CO2 equivalent) of 2000 in Ireland to that in Japan?
Offer a very short reply. 0.05. What is the ratio of the PFC emissions (in thousand metric tons of CO2 equivalent) of 2005 in Ireland to that in Japan?
Offer a terse response. 0.03. What is the ratio of the PFC emissions (in thousand metric tons of CO2 equivalent) of 2008 in Ireland to that in Japan?
Offer a terse response. 0.01. What is the ratio of the PFC emissions (in thousand metric tons of CO2 equivalent) in 1990 in Ireland to that in Korea (Republic)?
Your answer should be very brief. 0. What is the ratio of the PFC emissions (in thousand metric tons of CO2 equivalent) of 2000 in Ireland to that in Korea (Republic)?
Keep it short and to the point. 0.19. What is the ratio of the PFC emissions (in thousand metric tons of CO2 equivalent) of 2005 in Ireland to that in Korea (Republic)?
Provide a succinct answer. 0.09. What is the ratio of the PFC emissions (in thousand metric tons of CO2 equivalent) of 2008 in Ireland to that in Korea (Republic)?
Your answer should be very brief. 0.03. What is the ratio of the PFC emissions (in thousand metric tons of CO2 equivalent) of 1990 in Israel to that in Italy?
Your answer should be compact. 0.05. What is the ratio of the PFC emissions (in thousand metric tons of CO2 equivalent) in 2000 in Israel to that in Italy?
Give a very brief answer. 0.24. What is the ratio of the PFC emissions (in thousand metric tons of CO2 equivalent) of 2005 in Israel to that in Italy?
Provide a short and direct response. 0.28. What is the ratio of the PFC emissions (in thousand metric tons of CO2 equivalent) in 2008 in Israel to that in Italy?
Provide a succinct answer. 0.3. What is the ratio of the PFC emissions (in thousand metric tons of CO2 equivalent) of 1990 in Israel to that in Japan?
Provide a short and direct response. 0.01. What is the ratio of the PFC emissions (in thousand metric tons of CO2 equivalent) in 2000 in Israel to that in Japan?
Give a very brief answer. 0.01. What is the ratio of the PFC emissions (in thousand metric tons of CO2 equivalent) of 2005 in Israel to that in Japan?
Keep it short and to the point. 0.01. What is the ratio of the PFC emissions (in thousand metric tons of CO2 equivalent) of 2008 in Israel to that in Japan?
Offer a very short reply. 0.02. What is the ratio of the PFC emissions (in thousand metric tons of CO2 equivalent) of 1990 in Israel to that in Korea (Republic)?
Provide a short and direct response. 0.06. What is the ratio of the PFC emissions (in thousand metric tons of CO2 equivalent) in 2000 in Israel to that in Korea (Republic)?
Offer a terse response. 0.04. What is the ratio of the PFC emissions (in thousand metric tons of CO2 equivalent) in 2005 in Israel to that in Korea (Republic)?
Offer a very short reply. 0.04. What is the ratio of the PFC emissions (in thousand metric tons of CO2 equivalent) of 2008 in Israel to that in Korea (Republic)?
Your answer should be very brief. 0.04. What is the ratio of the PFC emissions (in thousand metric tons of CO2 equivalent) in 1990 in Italy to that in Japan?
Offer a terse response. 0.19. What is the ratio of the PFC emissions (in thousand metric tons of CO2 equivalent) in 2000 in Italy to that in Japan?
Make the answer very short. 0.04. What is the ratio of the PFC emissions (in thousand metric tons of CO2 equivalent) in 2005 in Italy to that in Japan?
Provide a short and direct response. 0.05. What is the ratio of the PFC emissions (in thousand metric tons of CO2 equivalent) in 2008 in Italy to that in Japan?
Offer a terse response. 0.06. What is the ratio of the PFC emissions (in thousand metric tons of CO2 equivalent) in 1990 in Italy to that in Korea (Republic)?
Ensure brevity in your answer.  1.11. What is the ratio of the PFC emissions (in thousand metric tons of CO2 equivalent) of 2000 in Italy to that in Korea (Republic)?
Keep it short and to the point. 0.18. What is the ratio of the PFC emissions (in thousand metric tons of CO2 equivalent) of 2005 in Italy to that in Korea (Republic)?
Your answer should be very brief. 0.16. What is the ratio of the PFC emissions (in thousand metric tons of CO2 equivalent) of 2008 in Italy to that in Korea (Republic)?
Your answer should be very brief. 0.15. What is the ratio of the PFC emissions (in thousand metric tons of CO2 equivalent) of 1990 in Japan to that in Korea (Republic)?
Keep it short and to the point. 6.01. What is the ratio of the PFC emissions (in thousand metric tons of CO2 equivalent) in 2000 in Japan to that in Korea (Republic)?
Give a very brief answer. 4.17. What is the ratio of the PFC emissions (in thousand metric tons of CO2 equivalent) of 2005 in Japan to that in Korea (Republic)?
Ensure brevity in your answer.  3.11. What is the ratio of the PFC emissions (in thousand metric tons of CO2 equivalent) of 2008 in Japan to that in Korea (Republic)?
Ensure brevity in your answer.  2.38. What is the difference between the highest and the second highest PFC emissions (in thousand metric tons of CO2 equivalent) of 1990?
Provide a succinct answer. 3829. What is the difference between the highest and the second highest PFC emissions (in thousand metric tons of CO2 equivalent) in 2000?
Make the answer very short. 6864.9. What is the difference between the highest and the second highest PFC emissions (in thousand metric tons of CO2 equivalent) in 2005?
Keep it short and to the point. 5169.9. What is the difference between the highest and the second highest PFC emissions (in thousand metric tons of CO2 equivalent) in 2008?
Offer a terse response. 3766. What is the difference between the highest and the lowest PFC emissions (in thousand metric tons of CO2 equivalent) in 1990?
Make the answer very short. 4698.6. What is the difference between the highest and the lowest PFC emissions (in thousand metric tons of CO2 equivalent) in 2000?
Offer a terse response. 8939.3. What is the difference between the highest and the lowest PFC emissions (in thousand metric tons of CO2 equivalent) of 2005?
Offer a very short reply. 7515.1. What is the difference between the highest and the lowest PFC emissions (in thousand metric tons of CO2 equivalent) of 2008?
Your answer should be very brief. 6412.5. 